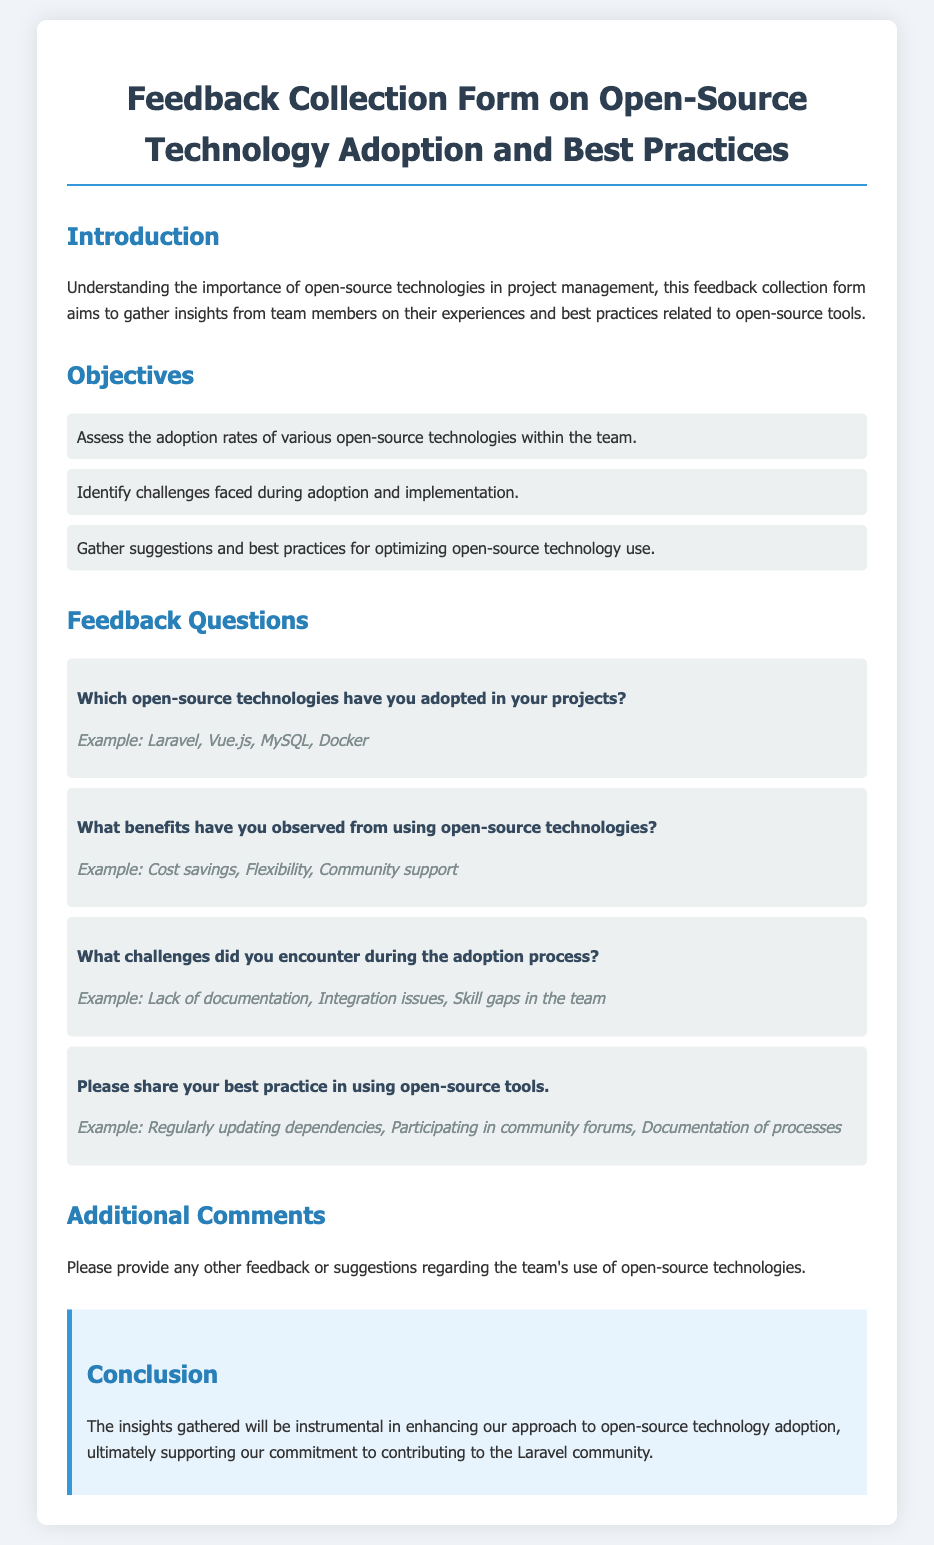Which open-source technologies are mentioned in the document? The document lists open-source technologies as examples in the feedback question section.
Answer: Laravel, Vue.js, MySQL, Docker What are the benefits of using open-source technologies? The document provides examples of benefits in the feedback question section.
Answer: Cost savings, Flexibility, Community support What challenges are highlighted during the adoption process? The challenges faced during adoption are listed as examples in the feedback question section.
Answer: Lack of documentation, Integration issues, Skill gaps in the team What is the main goal of the feedback collection form? The introduction section states the purpose of the feedback collection form clearly.
Answer: Gather insights from team members How many objectives are outlined in the document? The objectives section lists specific goals for the feedback collection form.
Answer: Three What is mentioned as a best practice for using open-source tools? The document includes examples of best practices in the feedback question section.
Answer: Regularly updating dependencies What additional comments section is asking for? The additional comments section invites further insights from respondents.
Answer: Feedback or suggestions regarding the team's use of open-source technologies What color is used for the conclusion heading? The document describes the style applied to section headings, including the conclusion.
Answer: Blue What is emphasized in the conclusion about the insights gathered? The conclusion summarizes the importance of insights for adopting open-source technologies.
Answer: Enhancing our approach to open-source technology adoption 